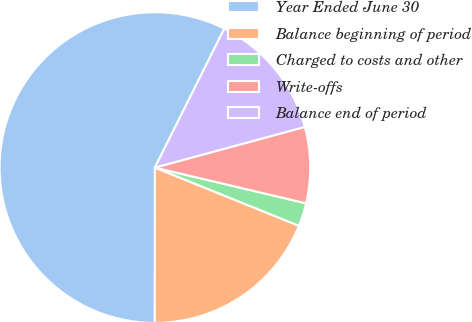<chart> <loc_0><loc_0><loc_500><loc_500><pie_chart><fcel>Year Ended June 30<fcel>Balance beginning of period<fcel>Charged to costs and other<fcel>Write-offs<fcel>Balance end of period<nl><fcel>57.36%<fcel>18.9%<fcel>2.42%<fcel>7.91%<fcel>13.41%<nl></chart> 